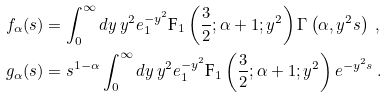Convert formula to latex. <formula><loc_0><loc_0><loc_500><loc_500>f _ { \alpha } ( s ) & = \int _ { 0 } ^ { \infty } d y \, y ^ { 2 } e ^ { - y ^ { 2 } } _ { 1 } \text {F} _ { 1 } \left ( \frac { 3 } { 2 } ; \alpha + 1 ; y ^ { 2 } \right ) \Gamma \left ( \alpha , y ^ { 2 } s \right ) \ , \\ g _ { \alpha } ( s ) & = s ^ { 1 - \alpha } \int _ { 0 } ^ { \infty } d y \, y ^ { 2 } e ^ { - y ^ { 2 } } _ { 1 } \text {F} _ { 1 } \left ( \frac { 3 } { 2 } ; \alpha + 1 ; y ^ { 2 } \right ) e ^ { - y ^ { 2 } s } \ .</formula> 